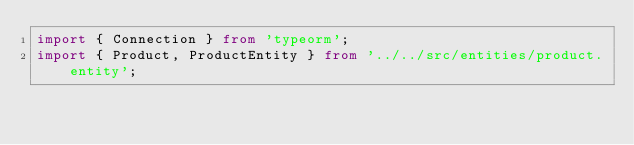<code> <loc_0><loc_0><loc_500><loc_500><_TypeScript_>import { Connection } from 'typeorm';
import { Product, ProductEntity } from '../../src/entities/product.entity';</code> 